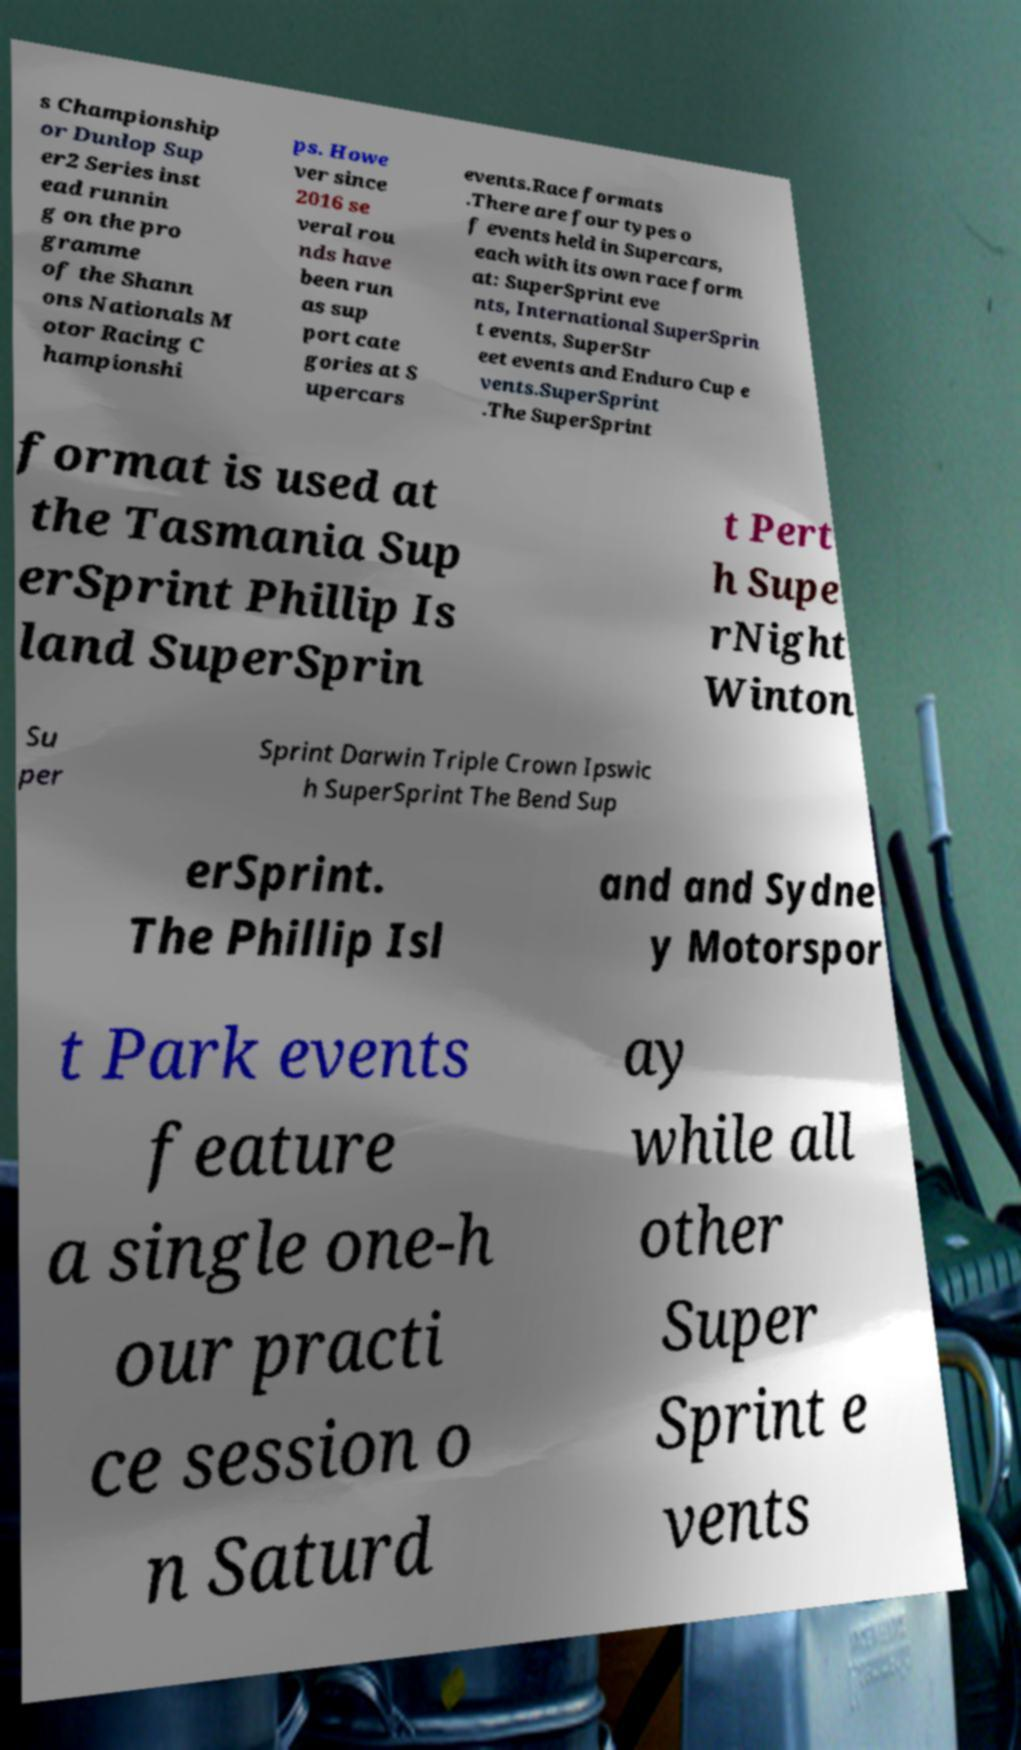Please identify and transcribe the text found in this image. s Championship or Dunlop Sup er2 Series inst ead runnin g on the pro gramme of the Shann ons Nationals M otor Racing C hampionshi ps. Howe ver since 2016 se veral rou nds have been run as sup port cate gories at S upercars events.Race formats .There are four types o f events held in Supercars, each with its own race form at: SuperSprint eve nts, International SuperSprin t events, SuperStr eet events and Enduro Cup e vents.SuperSprint .The SuperSprint format is used at the Tasmania Sup erSprint Phillip Is land SuperSprin t Pert h Supe rNight Winton Su per Sprint Darwin Triple Crown Ipswic h SuperSprint The Bend Sup erSprint. The Phillip Isl and and Sydne y Motorspor t Park events feature a single one-h our practi ce session o n Saturd ay while all other Super Sprint e vents 